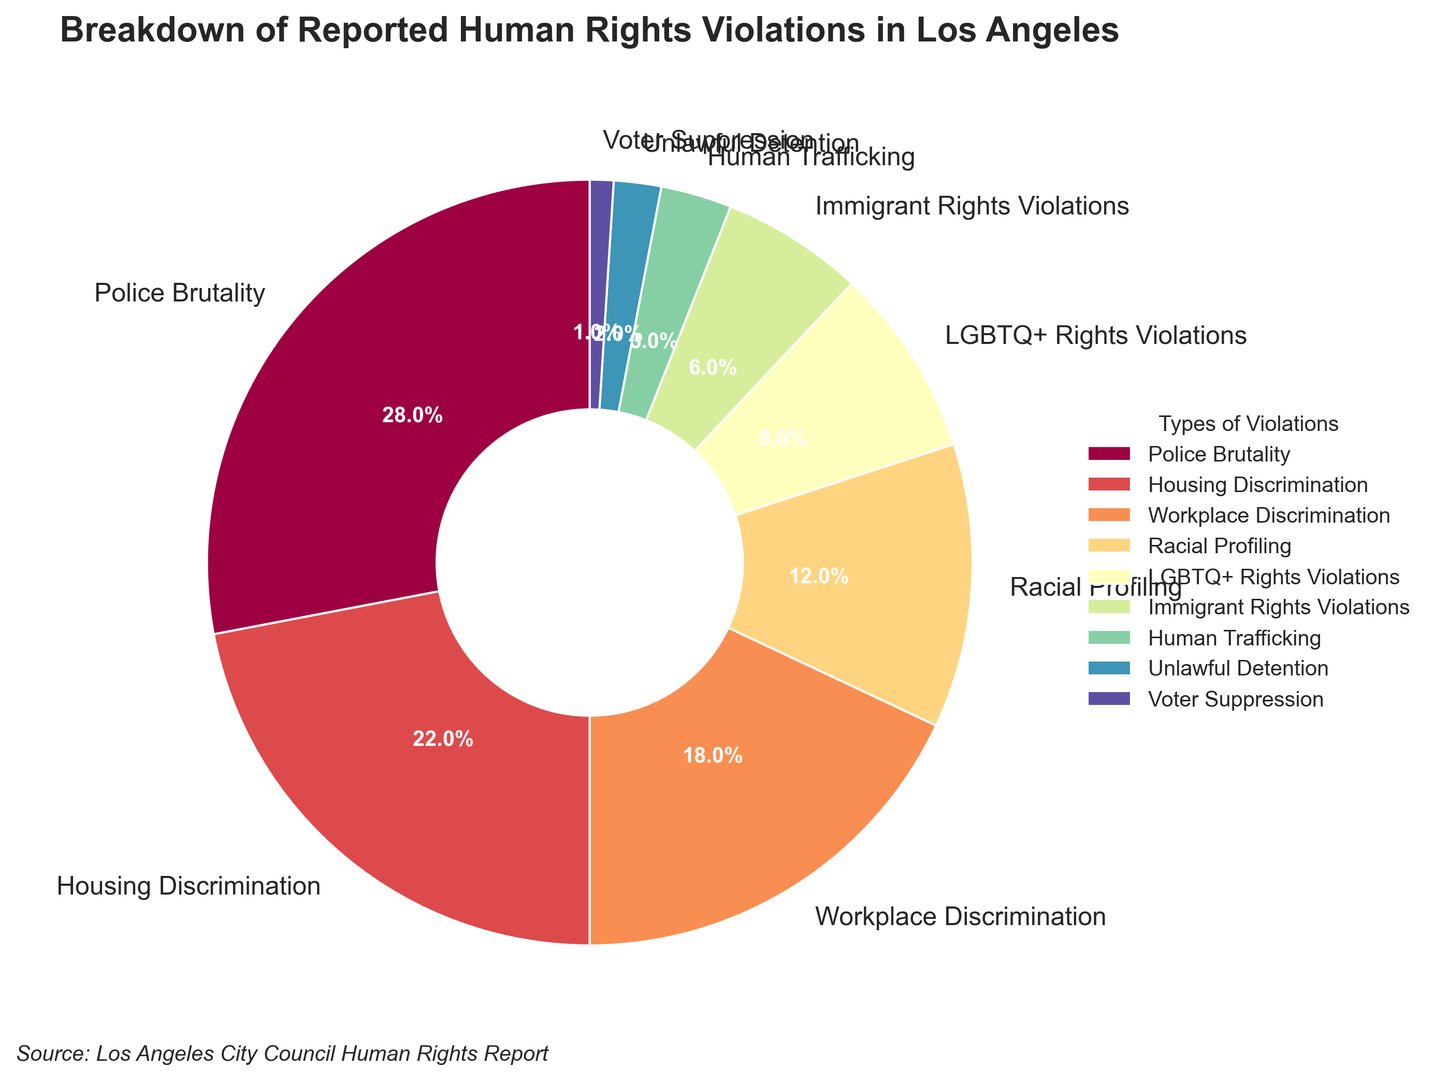Which type of human rights violation is the most reported in Los Angeles? By looking at the figure, we can see that the largest segment of the pie chart corresponds to Police Brutality, which has the highest percentage.
Answer: Police Brutality What is the combined percentage of Housing Discrimination and Workplace Discrimination? Housing Discrimination is 22% and Workplace Discrimination is 18%. Adding these together: 22% + 18% = 40%.
Answer: 40% Which type of human rights violation is reported the least? The smallest segment of the pie chart represents Voter Suppression, which has the lowest percentage.
Answer: Voter Suppression How much more frequently is Police Brutality reported compared to Immigrant Rights Violations? Police Brutality is 28% and Immigrant Rights Violations is 6%. Subtracting these values gives: 28% - 6% = 22%.
Answer: 22% What is the total percentage for reported violations related to discrimination (Housing and Workplace Discrimination)? Housing Discrimination is 22% and Workplace Discrimination is 18%. Adding these together: 22% + 18% = 40%.
Answer: 40% What is the percentage difference between Racial Profiling and LGBTQ+ Rights Violations? Racial Profiling is 12% and LGBTQ+ Rights Violations are 8%. Subtracting these values: 12% - 8% = 4%.
Answer: 4% Which category makes up more than a quarter of the reported violations? By looking at the figure, the only category with more than 25% of reported violations is Police Brutality.
Answer: Police Brutality What is the combined percentage for the three least reported types of violations? The three least reported types are Human Trafficking (3%), Unlawful Detention (2%), and Voter Suppression (1%). Adding these together: 3% + 2% + 1% = 6%.
Answer: 6% What is the difference in the percentage of reports between Police Brutality and Housing Discrimination? Police Brutality is 28% and Housing Discrimination is 22%. Subtracting these values gives: 28% - 22% = 6%.
Answer: 6% Which violation type has a percentage greater than 10% but less than 20%? By examining the segments, Workplace Discrimination fits this criterion with 18%.
Answer: Workplace Discrimination 